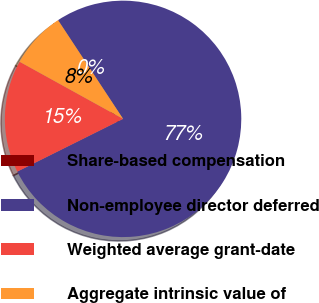<chart> <loc_0><loc_0><loc_500><loc_500><pie_chart><fcel>Share-based compensation<fcel>Non-employee director deferred<fcel>Weighted average grant-date<fcel>Aggregate intrinsic value of<nl><fcel>0.01%<fcel>76.91%<fcel>15.39%<fcel>7.7%<nl></chart> 